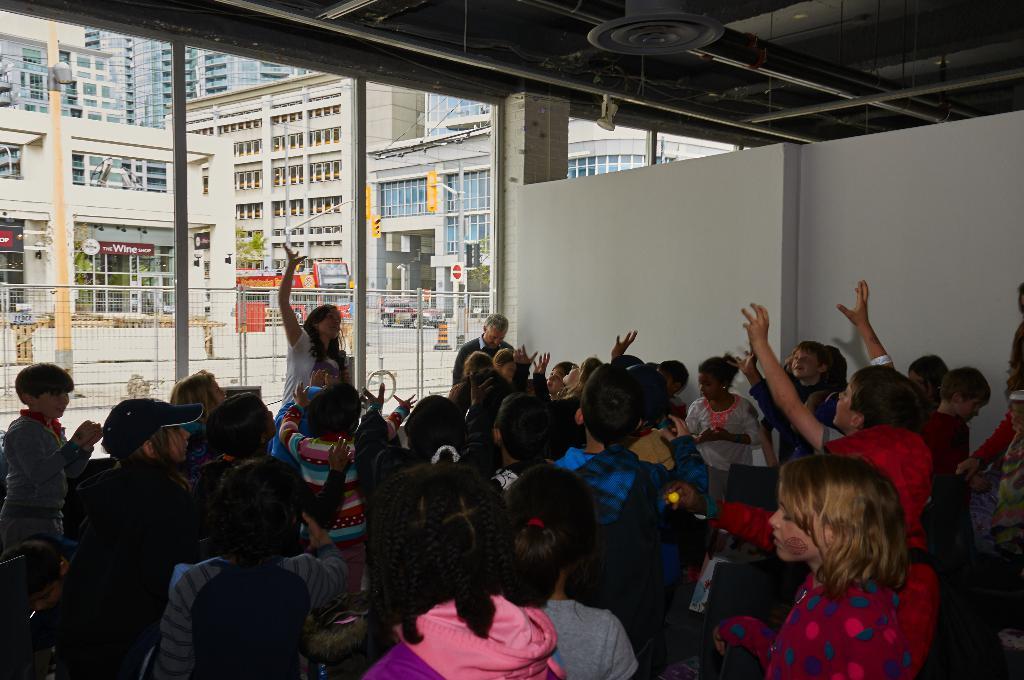Can you describe this image briefly? In this image I can see a group of people facing towards the back I can see three more people before them facing towards the right. I can see them under a shed. I can see some grills, buildings, sign boards, barricades outside the shed.  